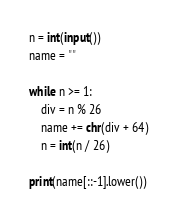Convert code to text. <code><loc_0><loc_0><loc_500><loc_500><_Python_>n = int(input())
name = ""

while n >= 1:
    div = n % 26
    name += chr(div + 64)
    n = int(n / 26)

print(name[::-1].lower())</code> 